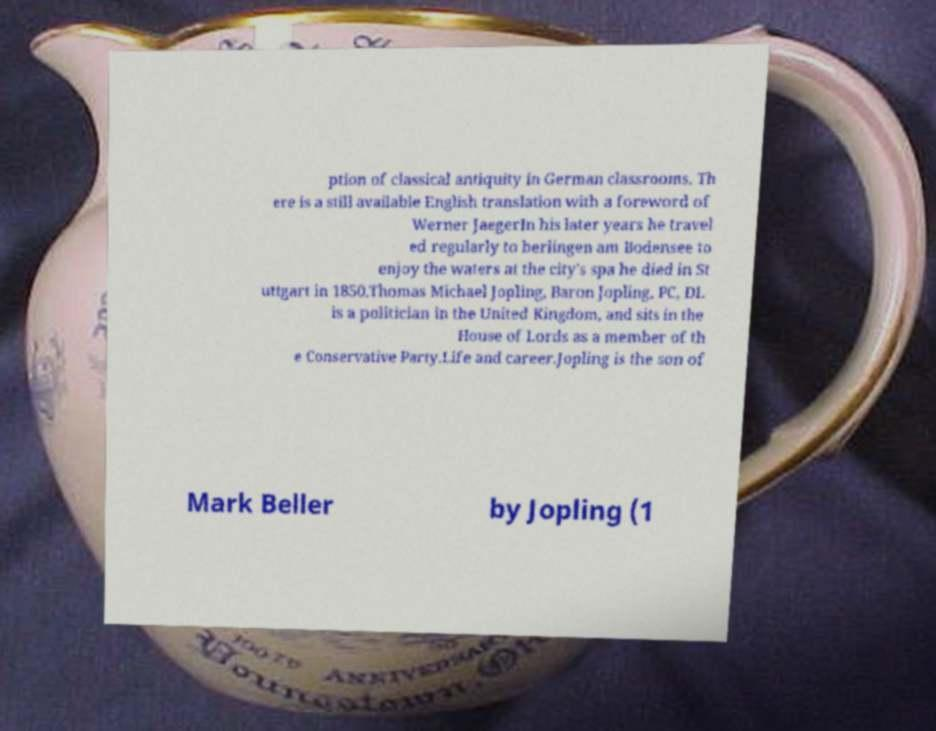Please read and relay the text visible in this image. What does it say? ption of classical antiquity in German classrooms. Th ere is a still available English translation with a foreword of Werner JaegerIn his later years he travel ed regularly to berlingen am Bodensee to enjoy the waters at the city's spa he died in St uttgart in 1850.Thomas Michael Jopling, Baron Jopling, PC, DL is a politician in the United Kingdom, and sits in the House of Lords as a member of th e Conservative Party.Life and career.Jopling is the son of Mark Beller by Jopling (1 